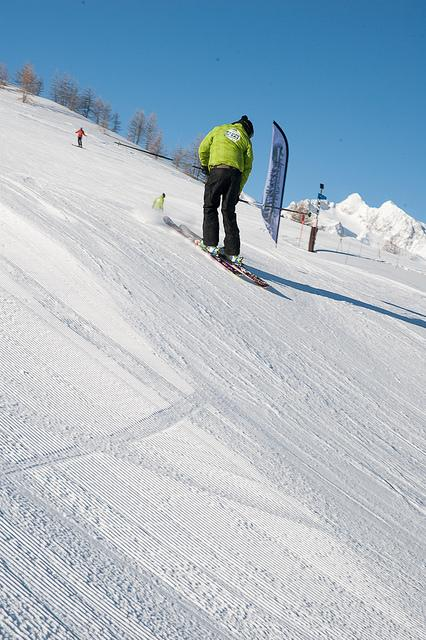What is this sport name? skiing 